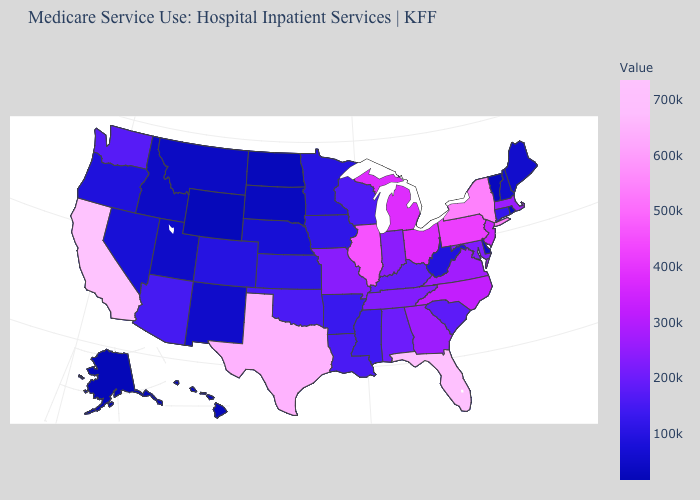Among the states that border Maryland , does West Virginia have the highest value?
Write a very short answer. No. Does Alaska have the lowest value in the USA?
Be succinct. Yes. Among the states that border Georgia , does Florida have the highest value?
Quick response, please. Yes. Which states hav the highest value in the Northeast?
Quick response, please. New York. 